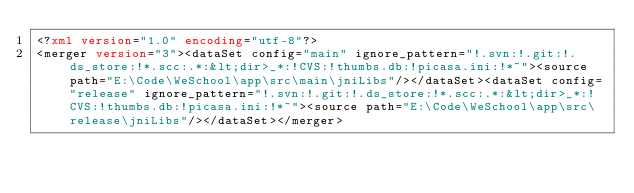<code> <loc_0><loc_0><loc_500><loc_500><_XML_><?xml version="1.0" encoding="utf-8"?>
<merger version="3"><dataSet config="main" ignore_pattern="!.svn:!.git:!.ds_store:!*.scc:.*:&lt;dir>_*:!CVS:!thumbs.db:!picasa.ini:!*~"><source path="E:\Code\WeSchool\app\src\main\jniLibs"/></dataSet><dataSet config="release" ignore_pattern="!.svn:!.git:!.ds_store:!*.scc:.*:&lt;dir>_*:!CVS:!thumbs.db:!picasa.ini:!*~"><source path="E:\Code\WeSchool\app\src\release\jniLibs"/></dataSet></merger></code> 